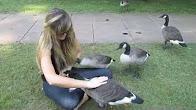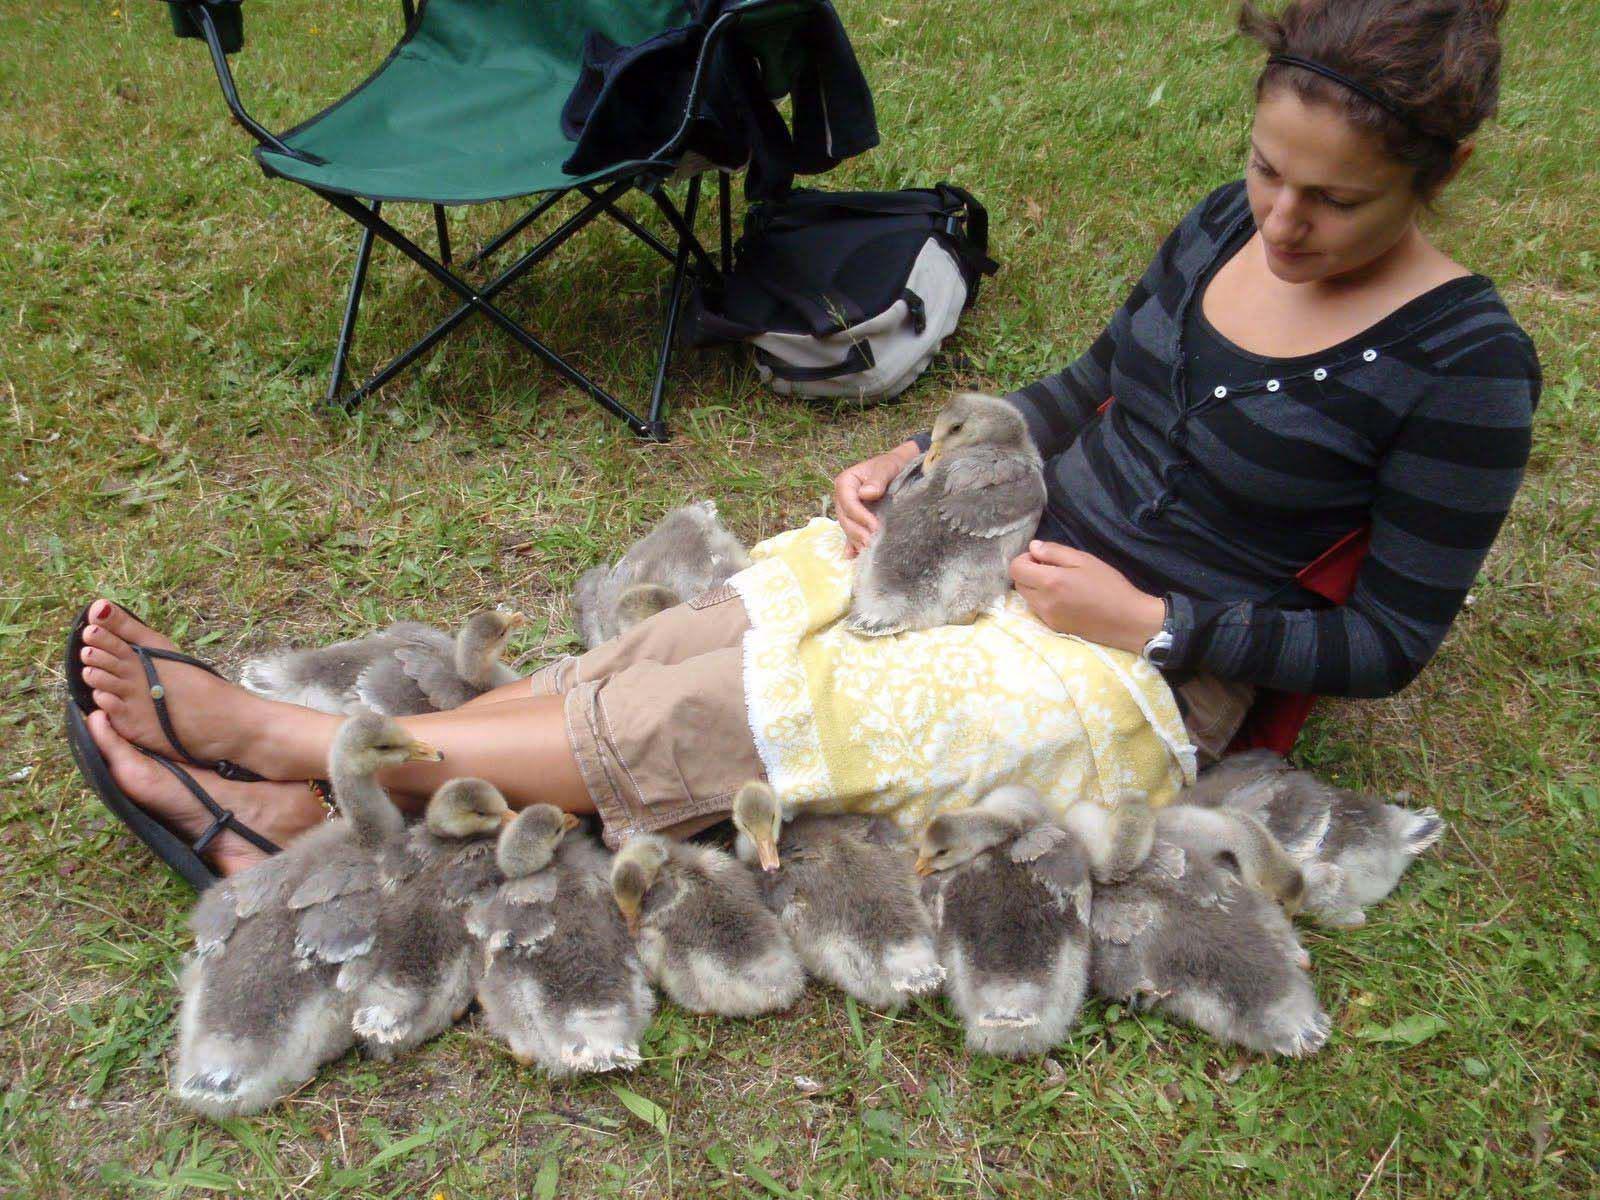The first image is the image on the left, the second image is the image on the right. Examine the images to the left and right. Is the description "A girl with long blonde hair is seated beside birds in one of the images." accurate? Answer yes or no. Yes. The first image is the image on the left, the second image is the image on the right. For the images displayed, is the sentence "The left image has at least 4 birds facing left." factually correct? Answer yes or no. Yes. 